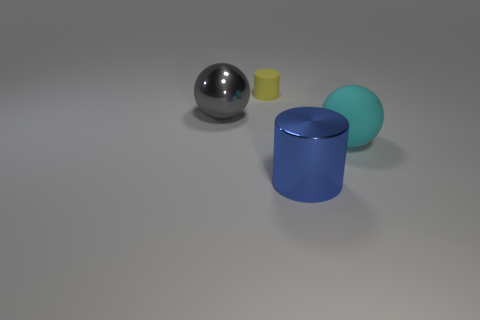Add 1 small gray cylinders. How many objects exist? 5 Subtract all blue cylinders. How many cylinders are left? 1 Subtract all blue cubes. How many purple cylinders are left? 0 Subtract all small objects. Subtract all big metallic things. How many objects are left? 1 Add 3 large gray things. How many large gray things are left? 4 Add 3 big red matte objects. How many big red matte objects exist? 3 Subtract 0 green blocks. How many objects are left? 4 Subtract 1 cylinders. How many cylinders are left? 1 Subtract all cyan cylinders. Subtract all gray cubes. How many cylinders are left? 2 